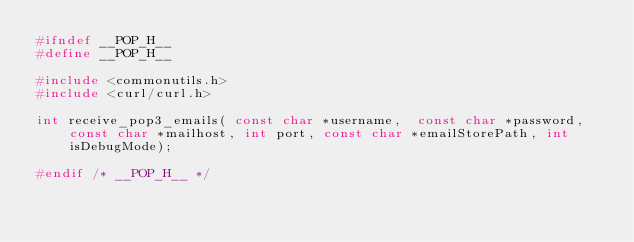Convert code to text. <code><loc_0><loc_0><loc_500><loc_500><_C_>#ifndef __POP_H__
#define __POP_H__

#include <commonutils.h>
#include <curl/curl.h>

int receive_pop3_emails( const char *username,  const char *password,  const char *mailhost, int port, const char *emailStorePath, int isDebugMode);

#endif /* __POP_H__ */

</code> 